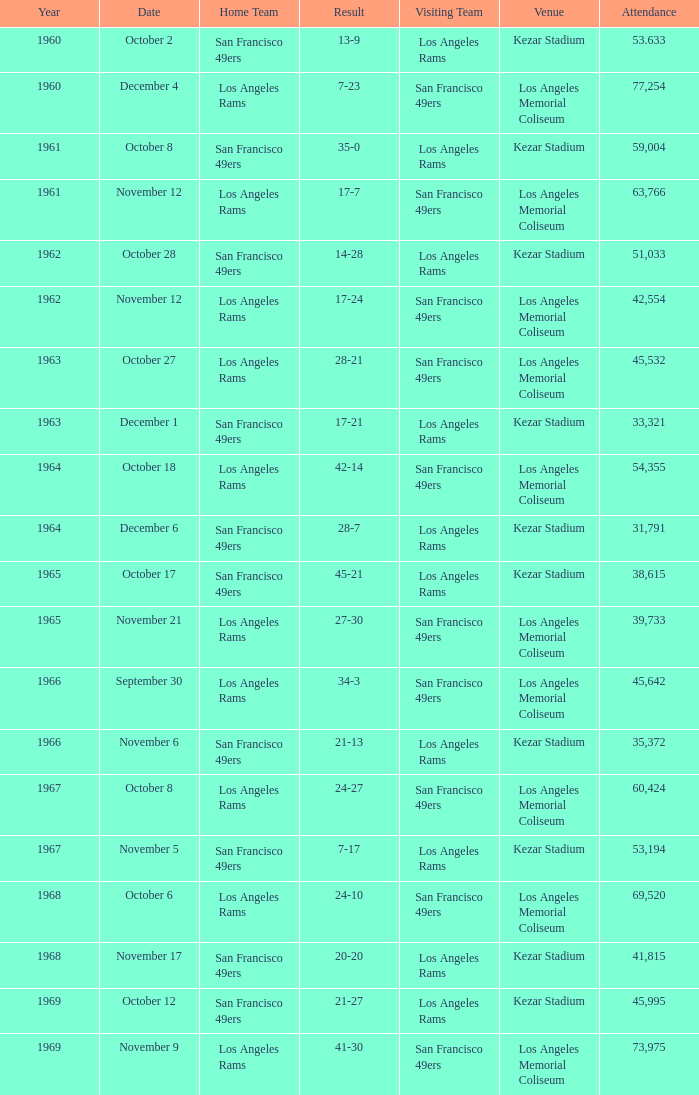Who is the home team when the san francisco 49ers are visiting with a result of 42-14? Los Angeles Rams. 